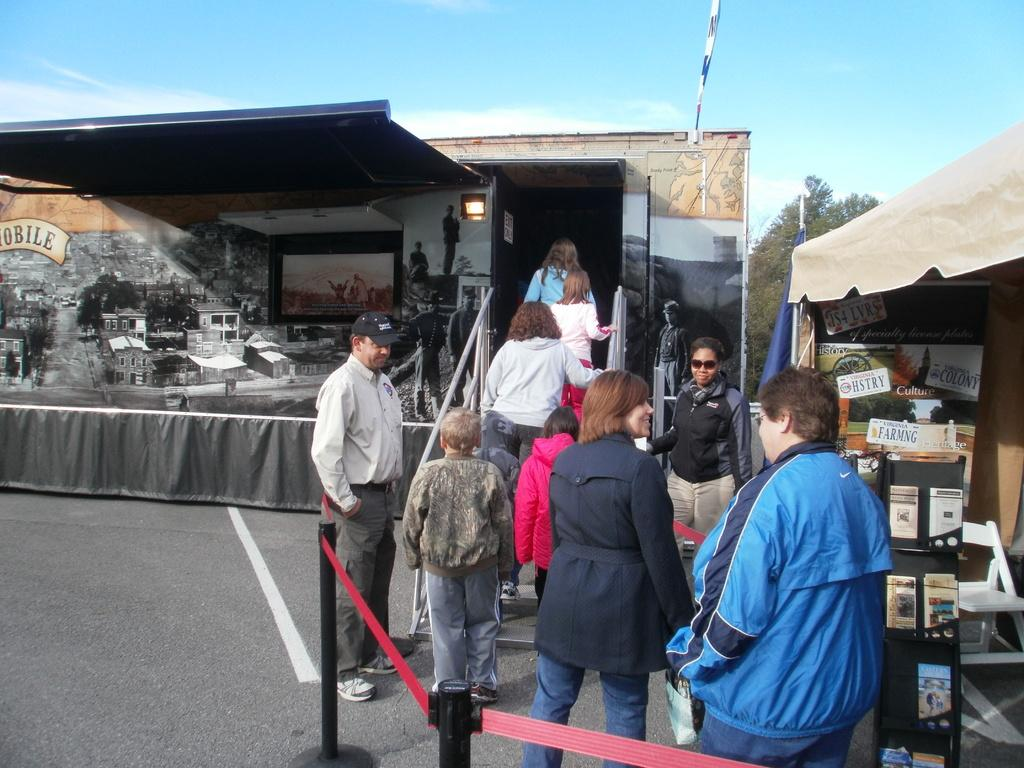<image>
Share a concise interpretation of the image provided. People waiting in line near a tent with Virginia license plates attached to the wall. 